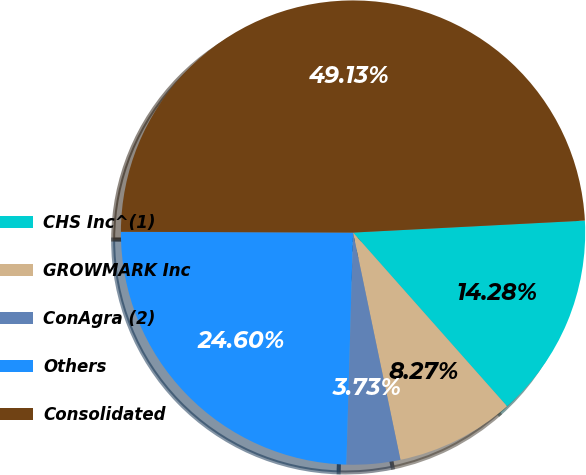Convert chart to OTSL. <chart><loc_0><loc_0><loc_500><loc_500><pie_chart><fcel>CHS Inc^(1)<fcel>GROWMARK Inc<fcel>ConAgra (2)<fcel>Others<fcel>Consolidated<nl><fcel>14.28%<fcel>8.27%<fcel>3.73%<fcel>24.6%<fcel>49.13%<nl></chart> 